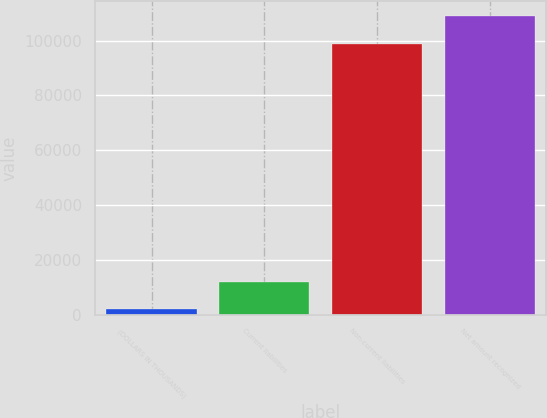Convert chart to OTSL. <chart><loc_0><loc_0><loc_500><loc_500><bar_chart><fcel>(DOLLARS IN THOUSANDS)<fcel>Current liabilities<fcel>Non-current liabilities<fcel>Net amount recognized<nl><fcel>2009<fcel>12009.2<fcel>98836<fcel>108836<nl></chart> 